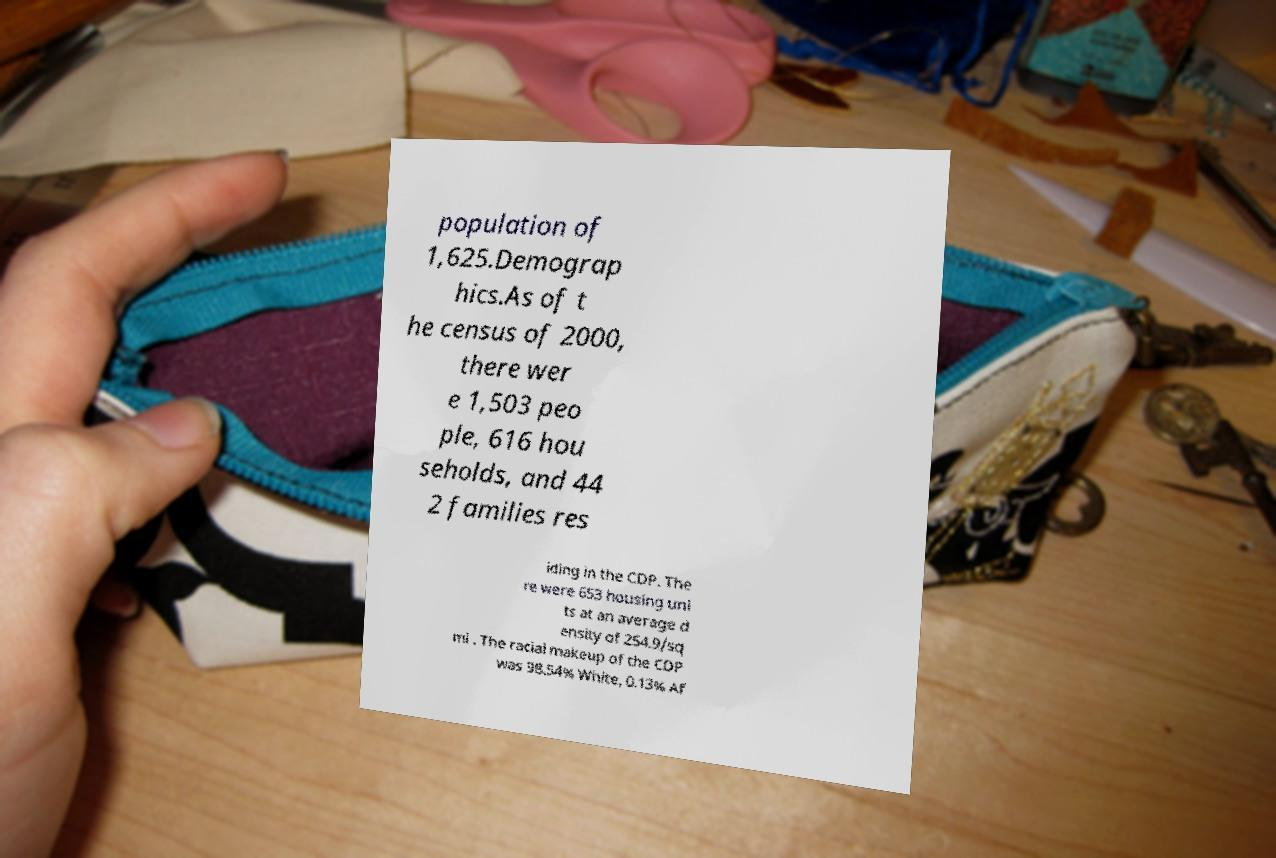For documentation purposes, I need the text within this image transcribed. Could you provide that? population of 1,625.Demograp hics.As of t he census of 2000, there wer e 1,503 peo ple, 616 hou seholds, and 44 2 families res iding in the CDP. The re were 653 housing uni ts at an average d ensity of 254.9/sq mi . The racial makeup of the CDP was 98.54% White, 0.13% Af 